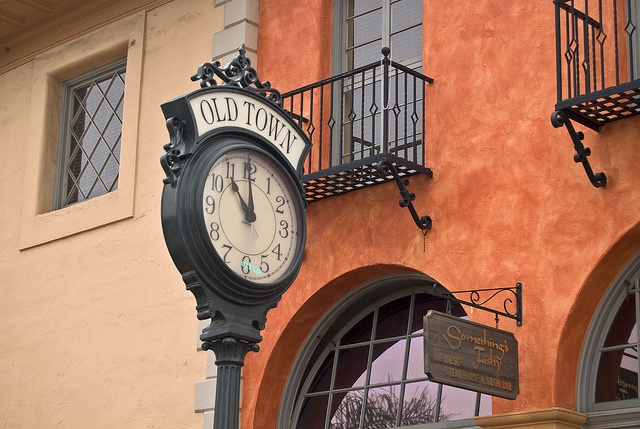Describe the objects in this image and their specific colors. I can see a clock in maroon, tan, gray, and darkgray tones in this image. 